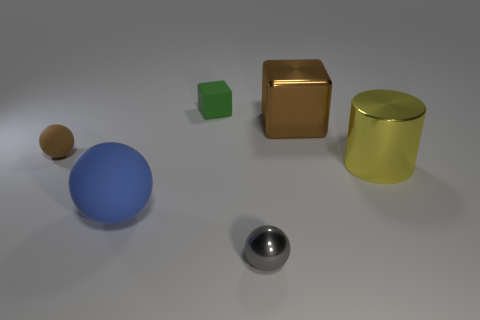Add 4 big green things. How many objects exist? 10 Subtract all cylinders. How many objects are left? 5 Subtract 1 brown cubes. How many objects are left? 5 Subtract all big metal cylinders. Subtract all brown rubber balls. How many objects are left? 4 Add 3 tiny brown matte balls. How many tiny brown matte balls are left? 4 Add 2 small blue metallic cubes. How many small blue metallic cubes exist? 2 